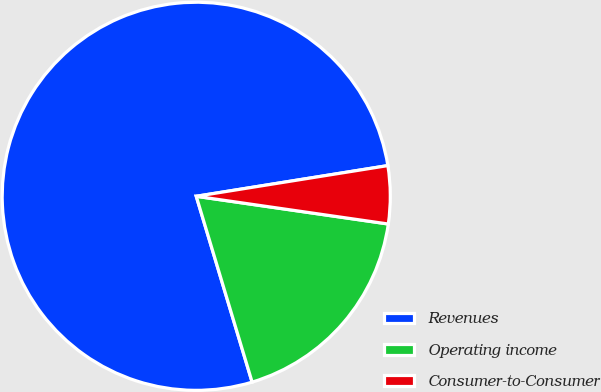Convert chart. <chart><loc_0><loc_0><loc_500><loc_500><pie_chart><fcel>Revenues<fcel>Operating income<fcel>Consumer-to-Consumer<nl><fcel>77.12%<fcel>18.07%<fcel>4.81%<nl></chart> 